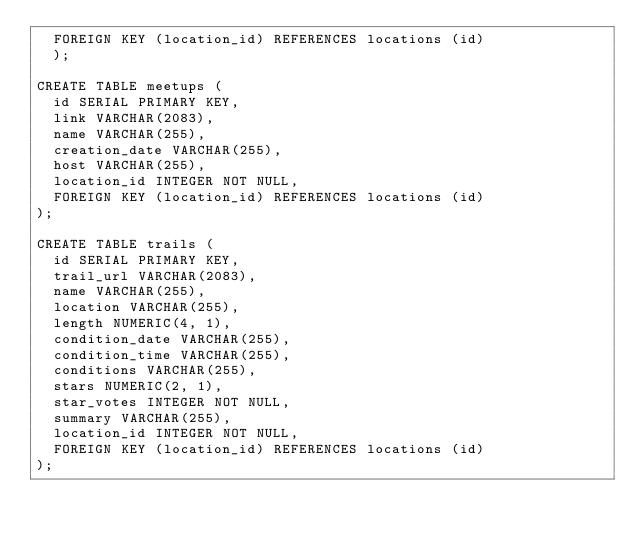<code> <loc_0><loc_0><loc_500><loc_500><_SQL_>  FOREIGN KEY (location_id) REFERENCES locations (id)
  );

CREATE TABLE meetups (
  id SERIAL PRIMARY KEY,
  link VARCHAR(2083),
  name VARCHAR(255),
  creation_date VARCHAR(255),
  host VARCHAR(255),
  location_id INTEGER NOT NULL,
  FOREIGN KEY (location_id) REFERENCES locations (id)
);

CREATE TABLE trails (
  id SERIAL PRIMARY KEY,
  trail_url VARCHAR(2083),
  name VARCHAR(255),
  location VARCHAR(255),
  length NUMERIC(4, 1),
  condition_date VARCHAR(255),
  condition_time VARCHAR(255),
  conditions VARCHAR(255),
  stars NUMERIC(2, 1),
  star_votes INTEGER NOT NULL,
  summary VARCHAR(255),
  location_id INTEGER NOT NULL,
  FOREIGN KEY (location_id) REFERENCES locations (id)
);</code> 